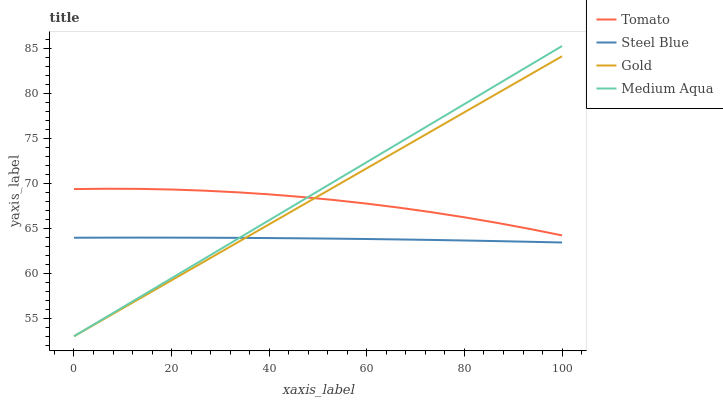Does Steel Blue have the minimum area under the curve?
Answer yes or no. Yes. Does Medium Aqua have the maximum area under the curve?
Answer yes or no. Yes. Does Medium Aqua have the minimum area under the curve?
Answer yes or no. No. Does Steel Blue have the maximum area under the curve?
Answer yes or no. No. Is Gold the smoothest?
Answer yes or no. Yes. Is Tomato the roughest?
Answer yes or no. Yes. Is Medium Aqua the smoothest?
Answer yes or no. No. Is Medium Aqua the roughest?
Answer yes or no. No. Does Steel Blue have the lowest value?
Answer yes or no. No. Does Steel Blue have the highest value?
Answer yes or no. No. Is Steel Blue less than Tomato?
Answer yes or no. Yes. Is Tomato greater than Steel Blue?
Answer yes or no. Yes. Does Steel Blue intersect Tomato?
Answer yes or no. No. 